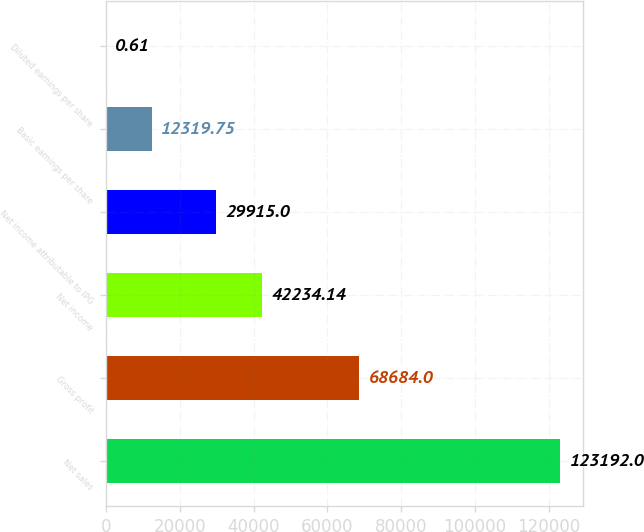Convert chart. <chart><loc_0><loc_0><loc_500><loc_500><bar_chart><fcel>Net sales<fcel>Gross profit<fcel>Net income<fcel>Net income attributable to IPG<fcel>Basic earnings per share<fcel>Diluted earnings per share<nl><fcel>123192<fcel>68684<fcel>42234.1<fcel>29915<fcel>12319.8<fcel>0.61<nl></chart> 